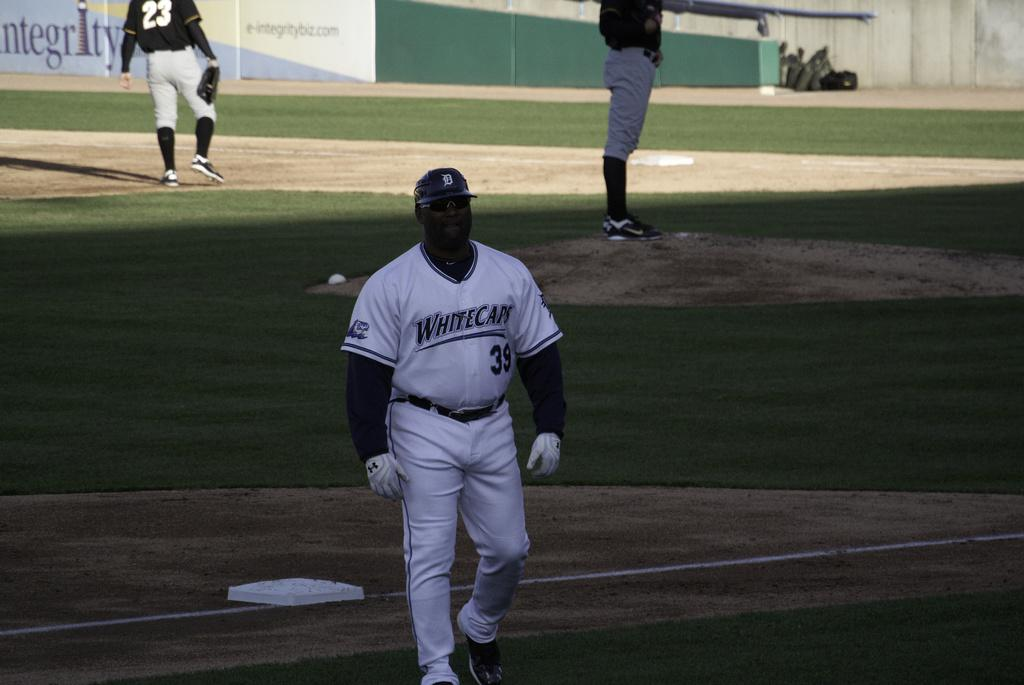<image>
Write a terse but informative summary of the picture. A person wearing a Whitecaps jersey walks on a baseball field. 